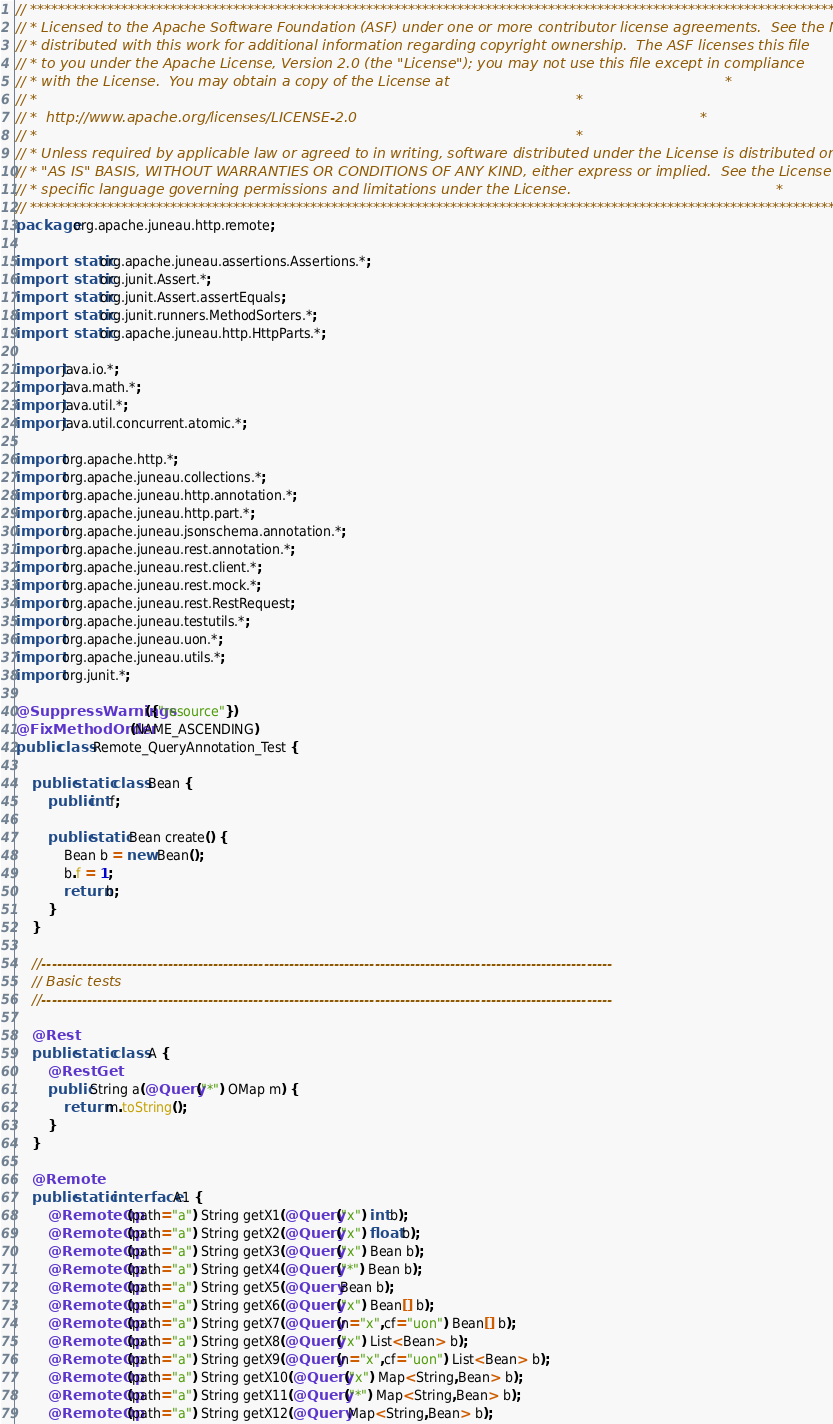<code> <loc_0><loc_0><loc_500><loc_500><_Java_>// ***************************************************************************************************************************
// * Licensed to the Apache Software Foundation (ASF) under one or more contributor license agreements.  See the NOTICE file *
// * distributed with this work for additional information regarding copyright ownership.  The ASF licenses this file        *
// * to you under the Apache License, Version 2.0 (the "License"); you may not use this file except in compliance            *
// * with the License.  You may obtain a copy of the License at                                                              *
// *                                                                                                                         *
// *  http://www.apache.org/licenses/LICENSE-2.0                                                                             *
// *                                                                                                                         *
// * Unless required by applicable law or agreed to in writing, software distributed under the License is distributed on an  *
// * "AS IS" BASIS, WITHOUT WARRANTIES OR CONDITIONS OF ANY KIND, either express or implied.  See the License for the        *
// * specific language governing permissions and limitations under the License.                                              *
// ***************************************************************************************************************************
package org.apache.juneau.http.remote;

import static org.apache.juneau.assertions.Assertions.*;
import static org.junit.Assert.*;
import static org.junit.Assert.assertEquals;
import static org.junit.runners.MethodSorters.*;
import static org.apache.juneau.http.HttpParts.*;

import java.io.*;
import java.math.*;
import java.util.*;
import java.util.concurrent.atomic.*;

import org.apache.http.*;
import org.apache.juneau.collections.*;
import org.apache.juneau.http.annotation.*;
import org.apache.juneau.http.part.*;
import org.apache.juneau.jsonschema.annotation.*;
import org.apache.juneau.rest.annotation.*;
import org.apache.juneau.rest.client.*;
import org.apache.juneau.rest.mock.*;
import org.apache.juneau.rest.RestRequest;
import org.apache.juneau.testutils.*;
import org.apache.juneau.uon.*;
import org.apache.juneau.utils.*;
import org.junit.*;

@SuppressWarnings({"resource"})
@FixMethodOrder(NAME_ASCENDING)
public class Remote_QueryAnnotation_Test {

	public static class Bean {
		public int f;

		public static Bean create() {
			Bean b = new Bean();
			b.f = 1;
			return b;
		}
	}

	//-----------------------------------------------------------------------------------------------------------------
	// Basic tests
	//-----------------------------------------------------------------------------------------------------------------

	@Rest
	public static class A {
		@RestGet
		public String a(@Query("*") OMap m) {
			return m.toString();
		}
	}

	@Remote
	public static interface A1 {
		@RemoteOp(path="a") String getX1(@Query("x") int b);
		@RemoteOp(path="a") String getX2(@Query("x") float b);
		@RemoteOp(path="a") String getX3(@Query("x") Bean b);
		@RemoteOp(path="a") String getX4(@Query("*") Bean b);
		@RemoteOp(path="a") String getX5(@Query Bean b);
		@RemoteOp(path="a") String getX6(@Query("x") Bean[] b);
		@RemoteOp(path="a") String getX7(@Query(n="x",cf="uon") Bean[] b);
		@RemoteOp(path="a") String getX8(@Query("x") List<Bean> b);
		@RemoteOp(path="a") String getX9(@Query(n="x",cf="uon") List<Bean> b);
		@RemoteOp(path="a") String getX10(@Query("x") Map<String,Bean> b);
		@RemoteOp(path="a") String getX11(@Query("*") Map<String,Bean> b);
		@RemoteOp(path="a") String getX12(@Query Map<String,Bean> b);</code> 